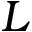<formula> <loc_0><loc_0><loc_500><loc_500>L</formula> 